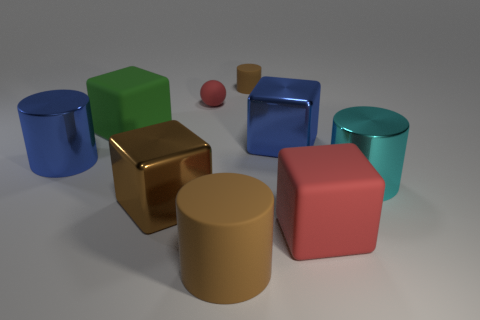There is another cylinder that is the same material as the big blue cylinder; what color is it?
Your answer should be very brief. Cyan. Is the large blue object that is to the left of the small brown matte cylinder made of the same material as the large blue thing to the right of the big brown cylinder?
Offer a terse response. Yes. Is there another ball that has the same size as the sphere?
Make the answer very short. No. There is a brown cylinder in front of the large brown object behind the big red rubber block; what is its size?
Your answer should be very brief. Large. How many large things have the same color as the tiny rubber cylinder?
Your answer should be very brief. 2. There is a blue metal object on the left side of the blue metal object that is behind the blue cylinder; what is its shape?
Offer a very short reply. Cylinder. What number of large green objects are the same material as the tiny red ball?
Offer a terse response. 1. What is the thing to the left of the green rubber thing made of?
Your response must be concise. Metal. What is the shape of the red rubber object to the right of the small red rubber thing behind the matte block behind the large blue cylinder?
Your answer should be compact. Cube. Is the color of the large cylinder that is left of the large green matte object the same as the large metal block behind the brown metal cube?
Your answer should be very brief. Yes. 